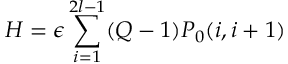<formula> <loc_0><loc_0><loc_500><loc_500>H = \epsilon \sum _ { i = 1 } ^ { 2 l - 1 } ( Q - 1 ) P _ { 0 } ( i , i + 1 )</formula> 